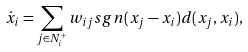<formula> <loc_0><loc_0><loc_500><loc_500>\dot { x } _ { i } = \sum _ { j \in N _ { i } ^ { + } } w _ { i j } s g n ( x _ { j } - x _ { i } ) d ( x _ { j } , x _ { i } ) ,</formula> 